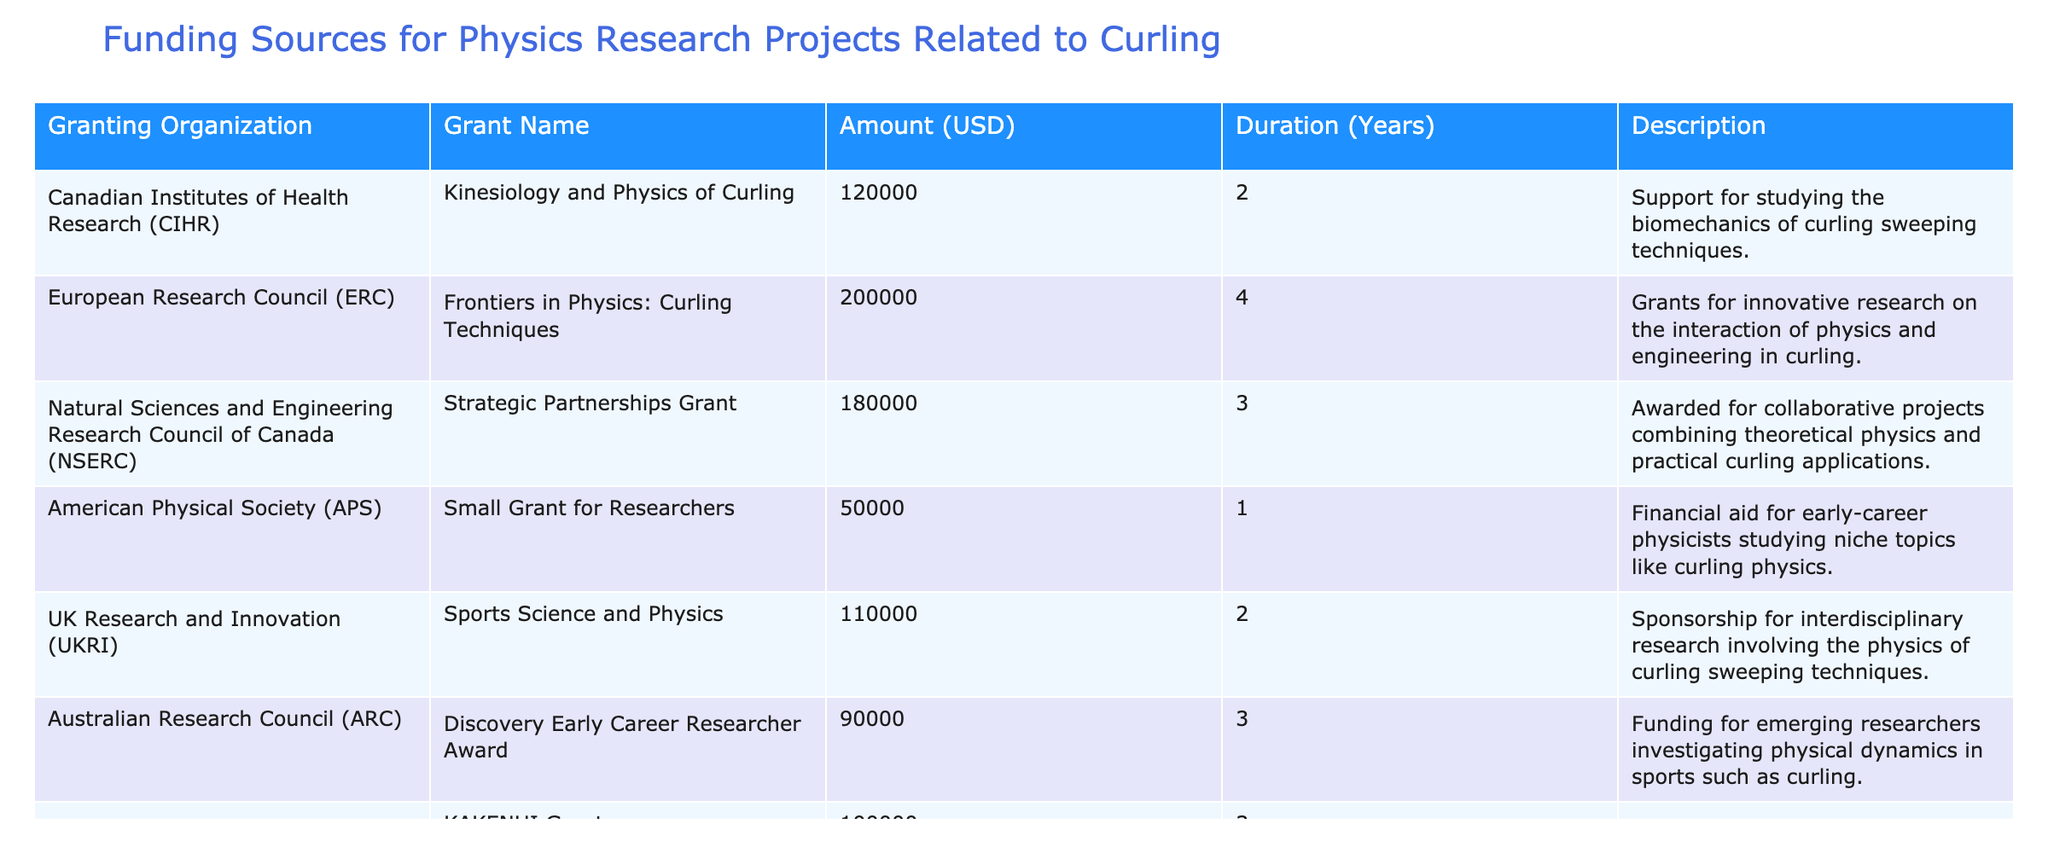What is the total amount of funding from the Canadian Institutes of Health Research? The amount of funding from the Canadian Institutes of Health Research (CIHR) is directly listed in the "Amount (USD)" column for that organization, which shows 120000.
Answer: 120000 Which granting organization provided the highest funding amount? To find the highest funding amount, we can compare all the values in the "Amount (USD)" column. The European Research Council (ERC) has the highest funding amount of 200000.
Answer: European Research Council (ERC) What is the average duration of the grants listed? To find the average duration, we sum the durations (2 + 4 + 3 + 1 + 2 + 3 + 3 = 18) and divide by the number of grants (7), yielding an average duration of 18 / 7 ≈ 2.57 years.
Answer: Approximately 2.57 years Is there a grant with a duration of 1 year? By looking through the "Duration (Years)" column, we can see that the American Physical Society (APS) has a duration of 1 year, confirming that there is indeed a grant with this duration.
Answer: Yes What percentage of the total funding comes from the smallest grant? The smallest grant amount is 50000 from the American Physical Society (APS). To calculate the total funding, we sum all amounts (120000 + 200000 + 180000 + 50000 + 110000 + 90000 + 100000 = 850000). The percentage is (50000 / 850000) * 100 ≈ 5.88%.
Answer: Approximately 5.88% Which grant has a description related to interdisciplinary research? By examining the "Description" column, the "Strategic Partnerships Grant" from Natural Sciences and Engineering Research Council of Canada is explicitly noted for combining theoretical physics and practical curling applications, which is interdisciplinary.
Answer: Strategic Partnerships Grant Are there any grants specifically for early-career researchers? Among the grants, the Discovery Early Career Researcher Award from the Australian Research Council specifies funding for emerging researchers, confirming that there is a grant specifically aimed at them.
Answer: Yes What is the total amount funded for projects with a duration of 3 years? We look at the grants with a duration of 3 years: NSERC (180000), ARC (90000), and JSPS (100000). Summing these amounts yields 180000 + 90000 + 100000 = 370000.
Answer: 370000 